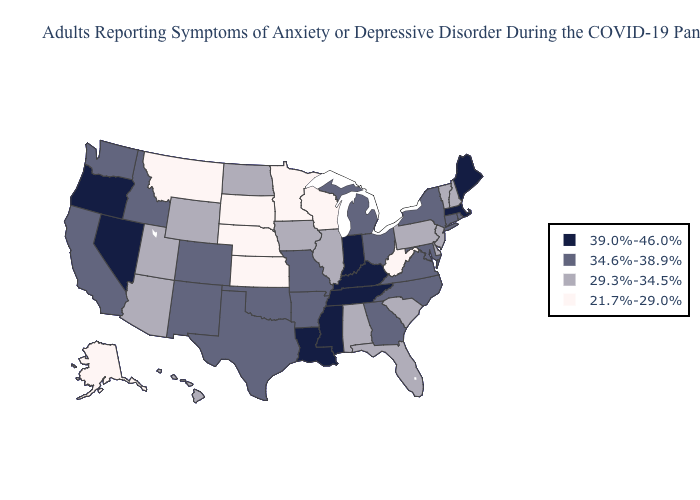Does Washington have a higher value than New Jersey?
Write a very short answer. Yes. Does the first symbol in the legend represent the smallest category?
Keep it brief. No. Name the states that have a value in the range 39.0%-46.0%?
Write a very short answer. Indiana, Kentucky, Louisiana, Maine, Massachusetts, Mississippi, Nevada, Oregon, Tennessee. Does Mississippi have the highest value in the South?
Concise answer only. Yes. What is the value of Virginia?
Write a very short answer. 34.6%-38.9%. Among the states that border Montana , which have the lowest value?
Be succinct. South Dakota. Does Oregon have the same value as Connecticut?
Be succinct. No. Name the states that have a value in the range 39.0%-46.0%?
Quick response, please. Indiana, Kentucky, Louisiana, Maine, Massachusetts, Mississippi, Nevada, Oregon, Tennessee. Does Mississippi have the highest value in the USA?
Keep it brief. Yes. What is the highest value in states that border Virginia?
Quick response, please. 39.0%-46.0%. Among the states that border Minnesota , which have the highest value?
Short answer required. Iowa, North Dakota. Which states hav the highest value in the South?
Write a very short answer. Kentucky, Louisiana, Mississippi, Tennessee. What is the highest value in states that border Nevada?
Concise answer only. 39.0%-46.0%. Among the states that border Oklahoma , does Missouri have the highest value?
Write a very short answer. Yes. Name the states that have a value in the range 34.6%-38.9%?
Give a very brief answer. Arkansas, California, Colorado, Connecticut, Georgia, Idaho, Maryland, Michigan, Missouri, New Mexico, New York, North Carolina, Ohio, Oklahoma, Rhode Island, Texas, Virginia, Washington. 